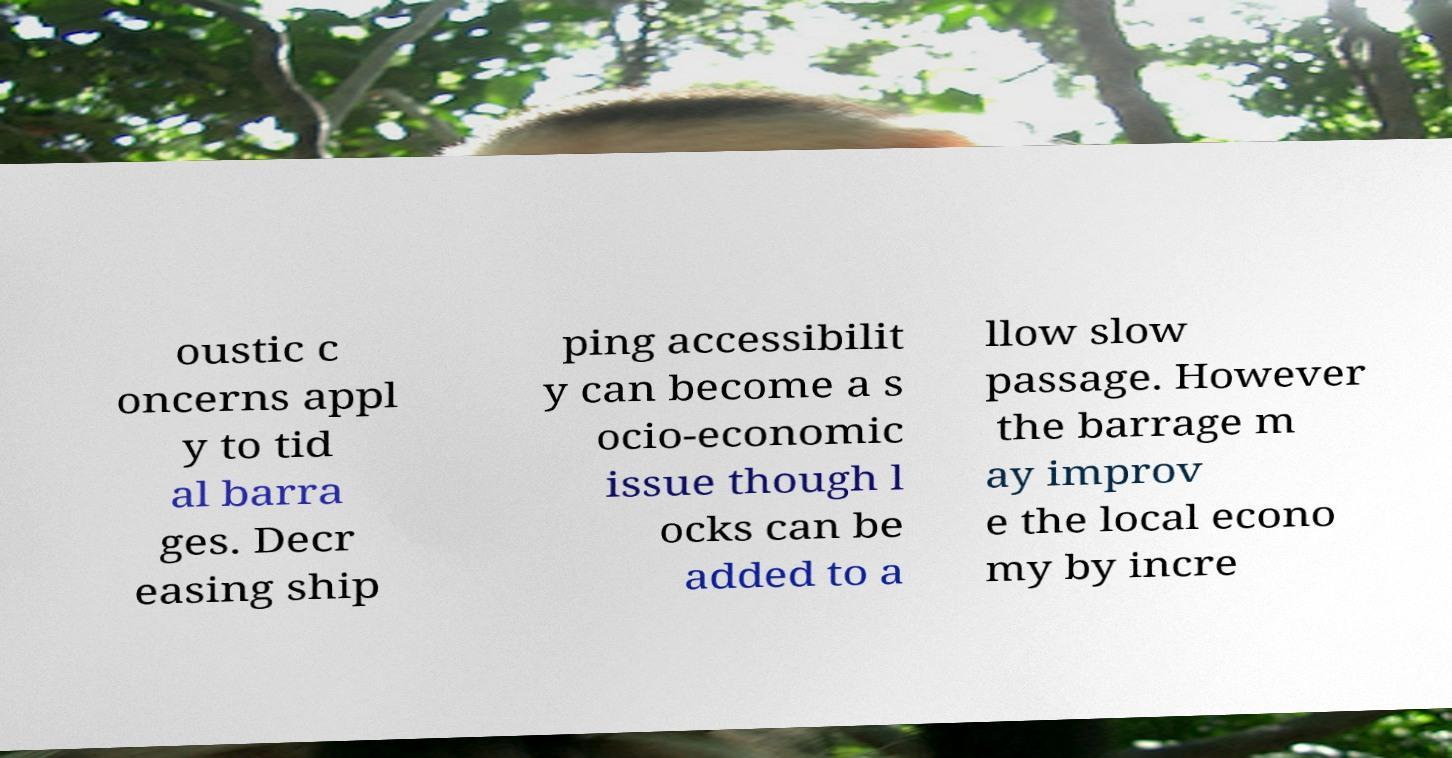Please identify and transcribe the text found in this image. oustic c oncerns appl y to tid al barra ges. Decr easing ship ping accessibilit y can become a s ocio-economic issue though l ocks can be added to a llow slow passage. However the barrage m ay improv e the local econo my by incre 